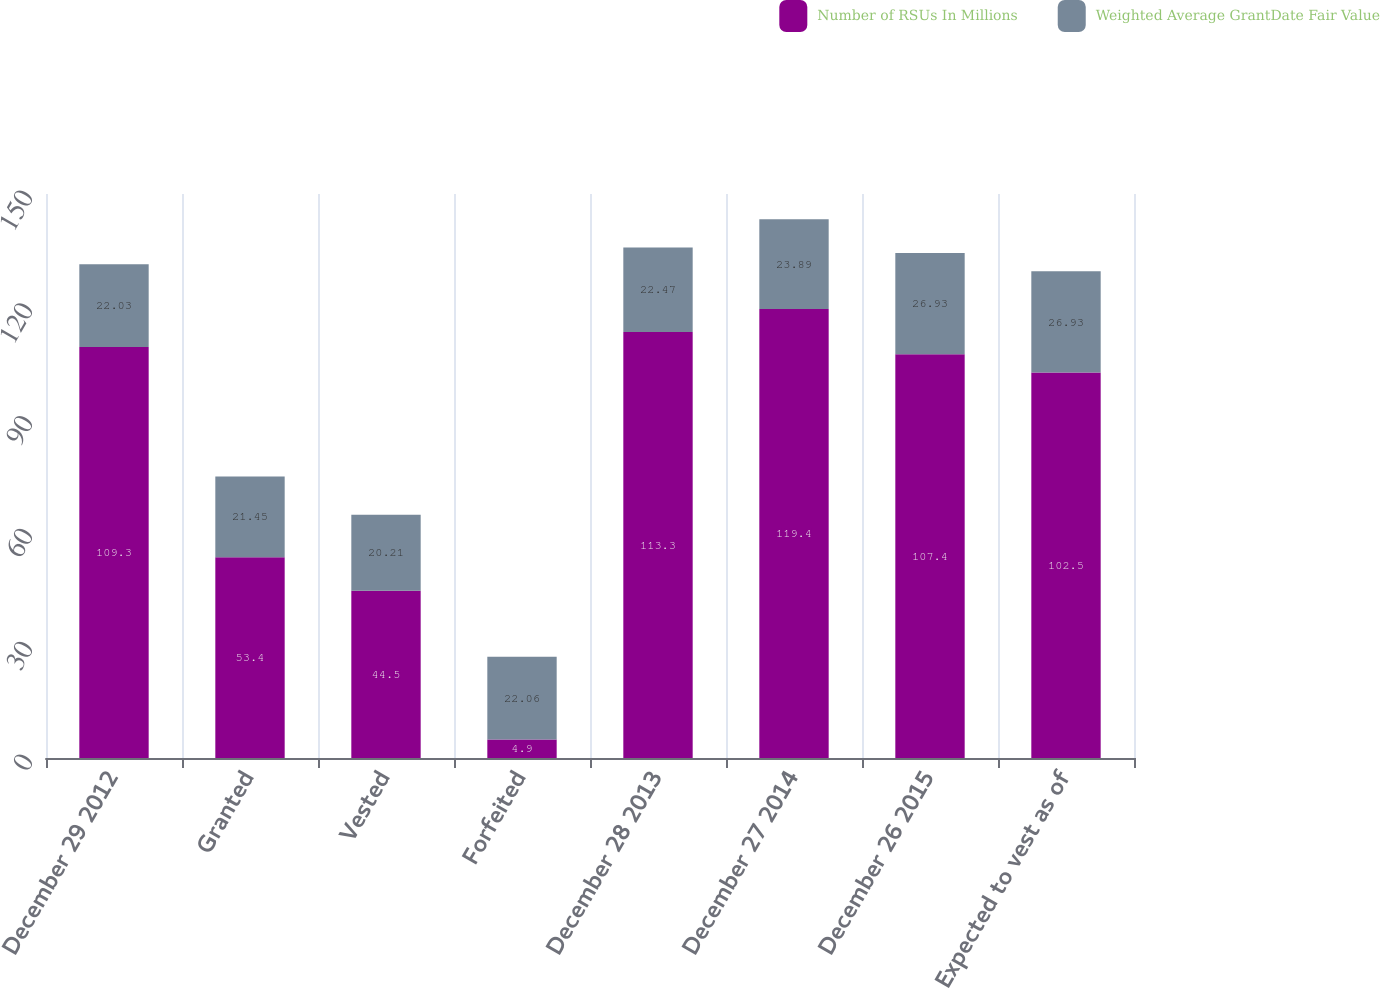Convert chart to OTSL. <chart><loc_0><loc_0><loc_500><loc_500><stacked_bar_chart><ecel><fcel>December 29 2012<fcel>Granted<fcel>Vested<fcel>Forfeited<fcel>December 28 2013<fcel>December 27 2014<fcel>December 26 2015<fcel>Expected to vest as of<nl><fcel>Number of RSUs In Millions<fcel>109.3<fcel>53.4<fcel>44.5<fcel>4.9<fcel>113.3<fcel>119.4<fcel>107.4<fcel>102.5<nl><fcel>Weighted Average GrantDate Fair Value<fcel>22.03<fcel>21.45<fcel>20.21<fcel>22.06<fcel>22.47<fcel>23.89<fcel>26.93<fcel>26.93<nl></chart> 